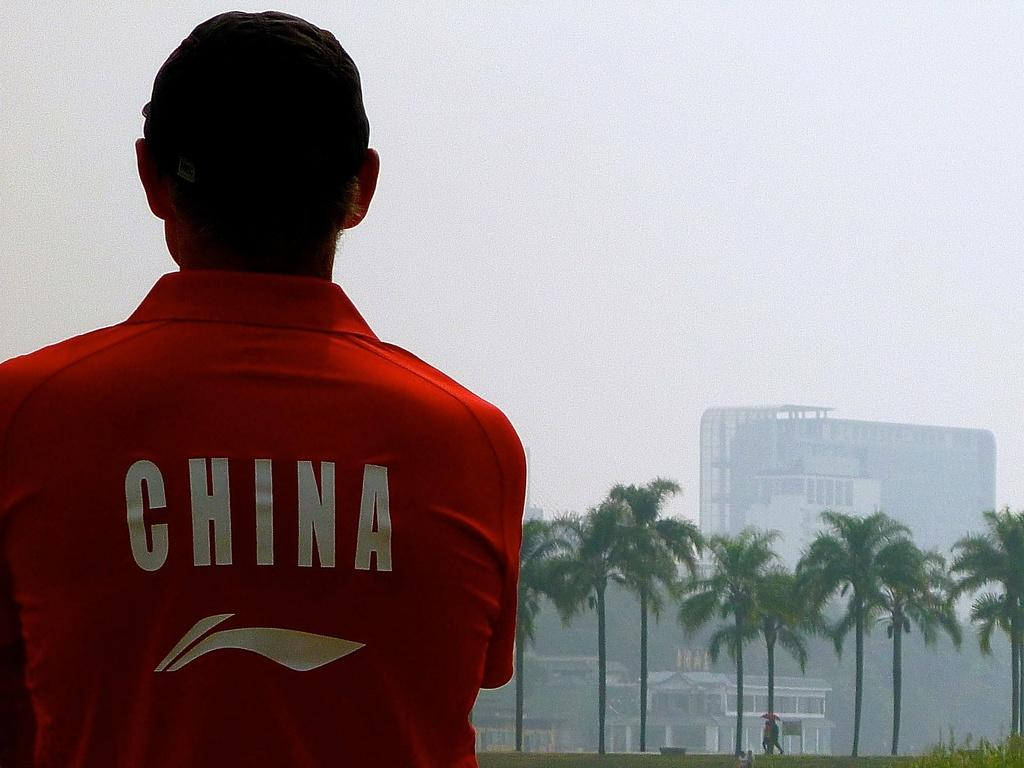<image>
Relay a brief, clear account of the picture shown. Man waring a Red Shirt that says CHINA in red letters, he is looking in the distance of palm trees and a building. 